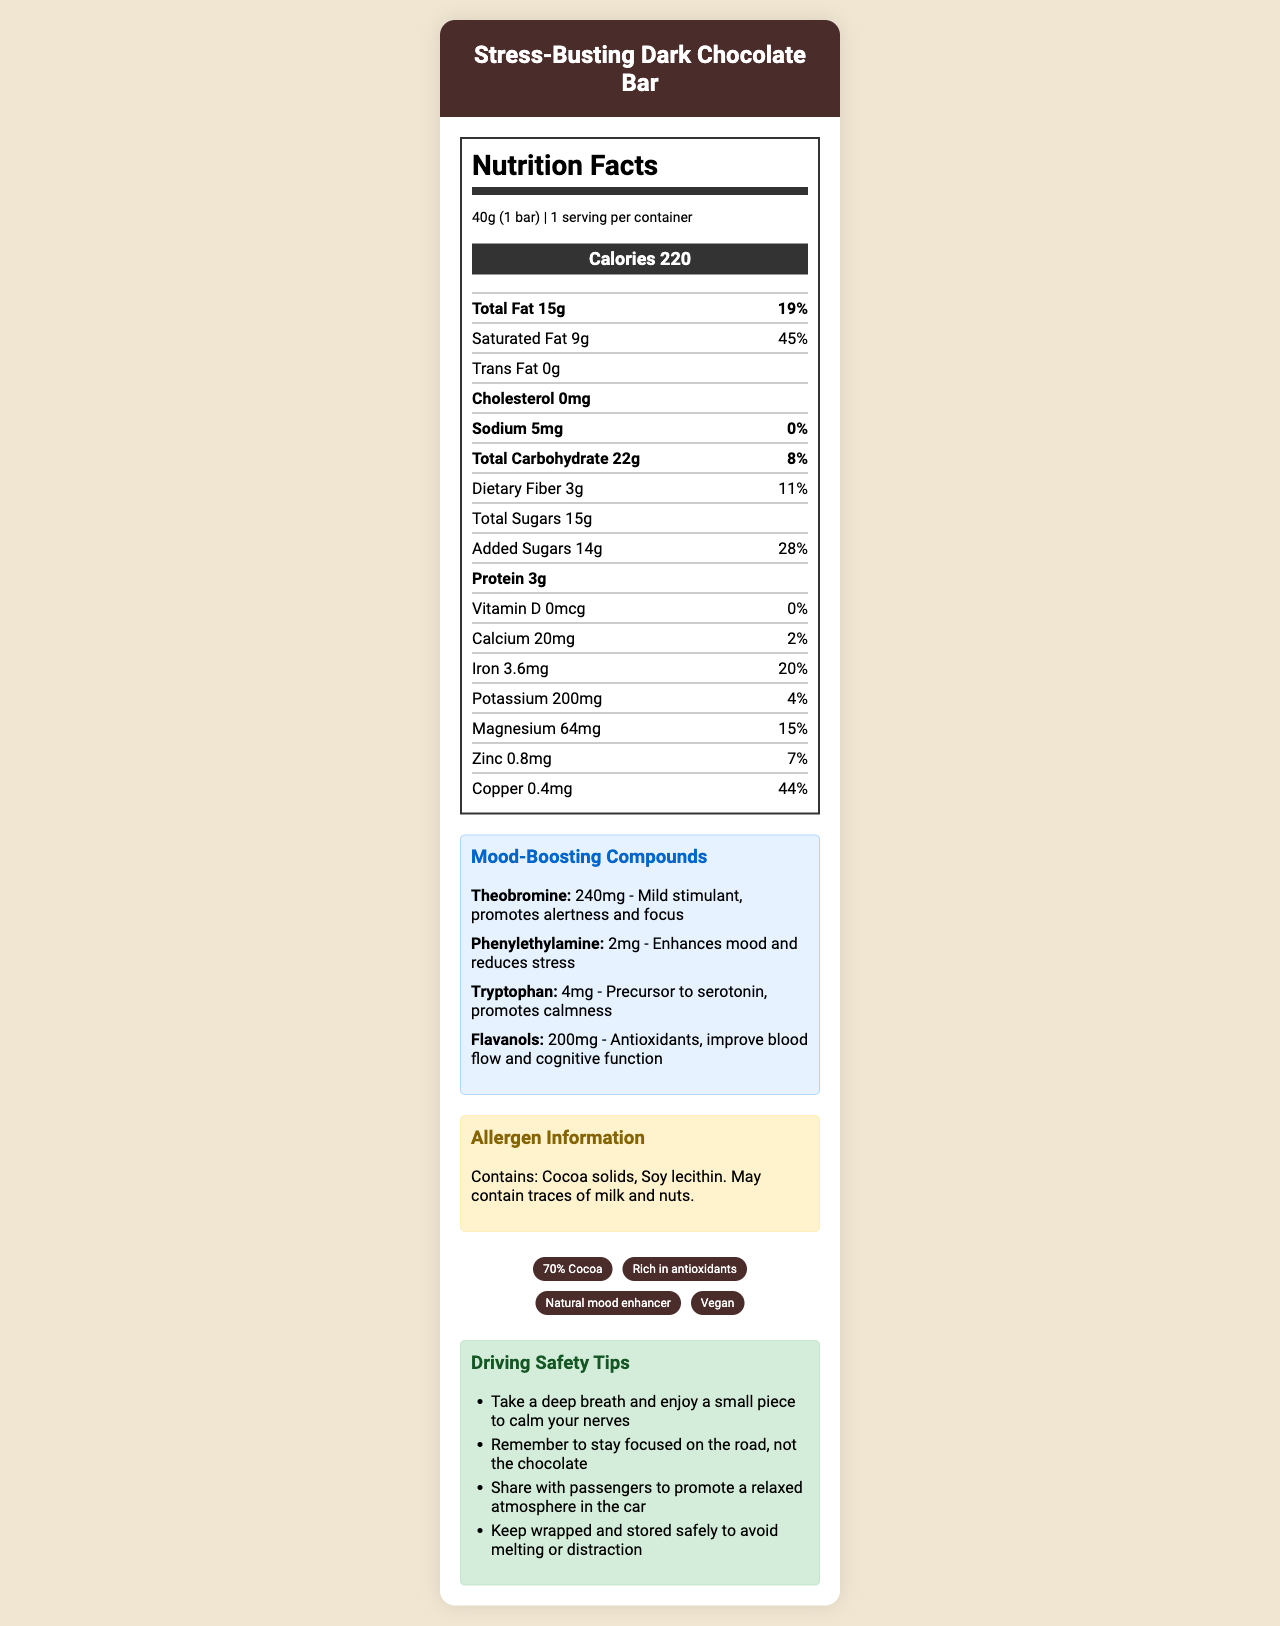what is the serving size? The document states "serving size" as "40g (1 bar)".
Answer: 40g (1 bar) how many calories are in one serving? The document provides "calories per serving" as "220".
Answer: 220 what is the total fat content in one serving? The document lists "total fat" as "15g".
Answer: 15g how much added sugar is in one bar? The document states "added sugars" are "14g".
Answer: 14g what is the percentage of daily value for iron in one serving? The document indicates the "percent daily value" for iron is "20%" for one serving.
Answer: 20% which mood-boosting compound in the chocolate bar acts as a mild stimulant? A. Theobromine B. Phenylethylamine C. Tryptophan D. Flavanols The document mentions "Theobromine" as a "Mild stimulant" that "promotes alertness and focus".
Answer: A. Theobromine what benefit does Phenylethylamine provide in the chocolate bar? A. Enhances mood and reduces stress B. Precursor to serotonin, promotes calmness C. Mild stimulant, promotes alertness and focus D. Antioxidants, improve blood flow and cognitive function The document states that "Phenylethylamine" "Enhances mood and reduces stress".
Answer: A. Enhances mood and reduces stress does the chocolate bar contain any cholesterol? The document specifies "cholesterol" as "0mg", indicating no cholesterol.
Answer: No what are the main allergen concerns listed for this chocolate bar? The document includes an allergen information section stating "Contains: Cocoa solids, Soy lecithin. May contain traces of milk and nuts."
Answer: Cocoa solids, Soy lecithin. May contain traces of milk and nuts. what types of safety tips are provided for drivers consuming this chocolate bar? The document lists 4 safety tips for drivers in a bulleted format.
Answer: Take a deep breath and enjoy a small piece to calm your nerves; Remember to stay focused on the road, not the chocolate; Share with passengers to promote a relaxed atmosphere in the car; Keep wrapped and stored safely to avoid melting or distraction what are the main features highlighted about this chocolate bar? The document has a section for claims including "70% Cocoa", "Rich in antioxidants", "Natural mood enhancer", and "Vegan".
Answer: 70% Cocoa, Rich in antioxidants, Natural mood enhancer, Vegan summarize the main idea of this document. The document thoroughly describes the nutritional content and the mood-boosting properties of the "Stress-Busting Dark Chocolate Bar", including its compounds, allergen information, and driving safety tips along with key product claims.
Answer: The document provides a detailed nutritional profile for the "Stress-Busting Dark Chocolate Bar", highlighting its mood-boosting properties. It includes information about serving size, calorie content, fats, cholesterol, sodium, carbohydrates, sugars, protein, vitamins, and minerals. It details the benefits of compounds like Theobromine, Phenylethylamine, Tryptophan, and Flavanols for mood enhancement. Allergen information, product claims, and driving safety tips are also provided. are there any vitamin D in the chocolate bar? The document shows "vitamin D" as "0mcg" and "% Daily Value" as "0%", indicating that there is no vitamin D in the chocolate bar.
Answer: No what is the recommended calorie intake percentage for added sugars in the bar given the daily value? A. 10% B. 14% C. 20% D. 28% The document indicates the added sugars are 14g and the "percent daily value" is "28%".
Answer: D. 28% 